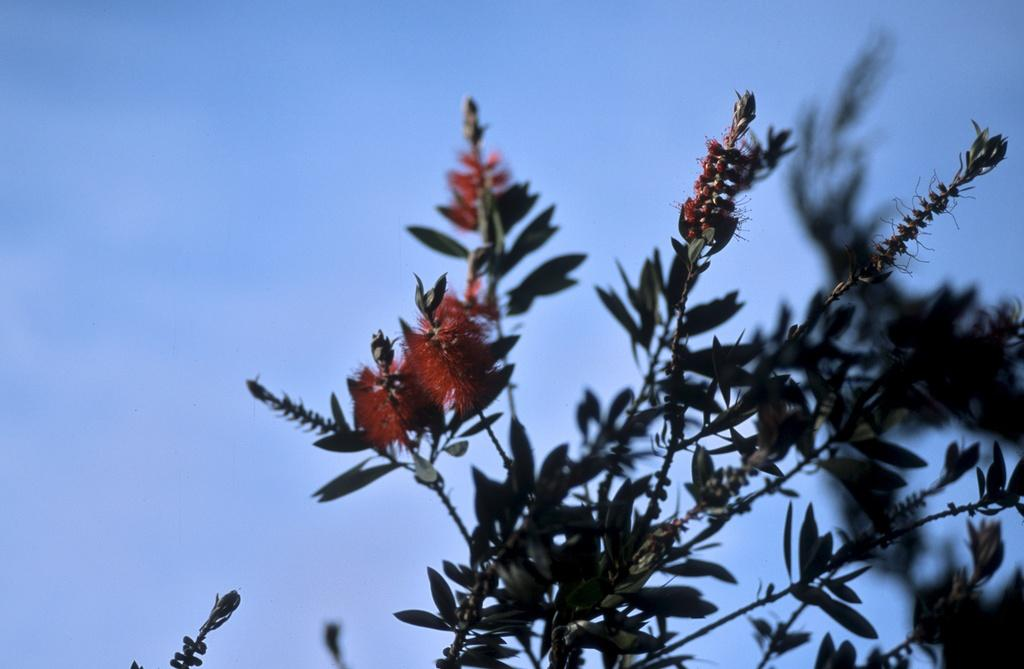What type of plant can be seen in the image? There is a plant with flowers in the image. What can be seen in the background of the image? The sky is visible in the background of the image. What type of drug is being used by the plant in the image? There is no drug present in the image; it features a plant with flowers and the sky in the background. 